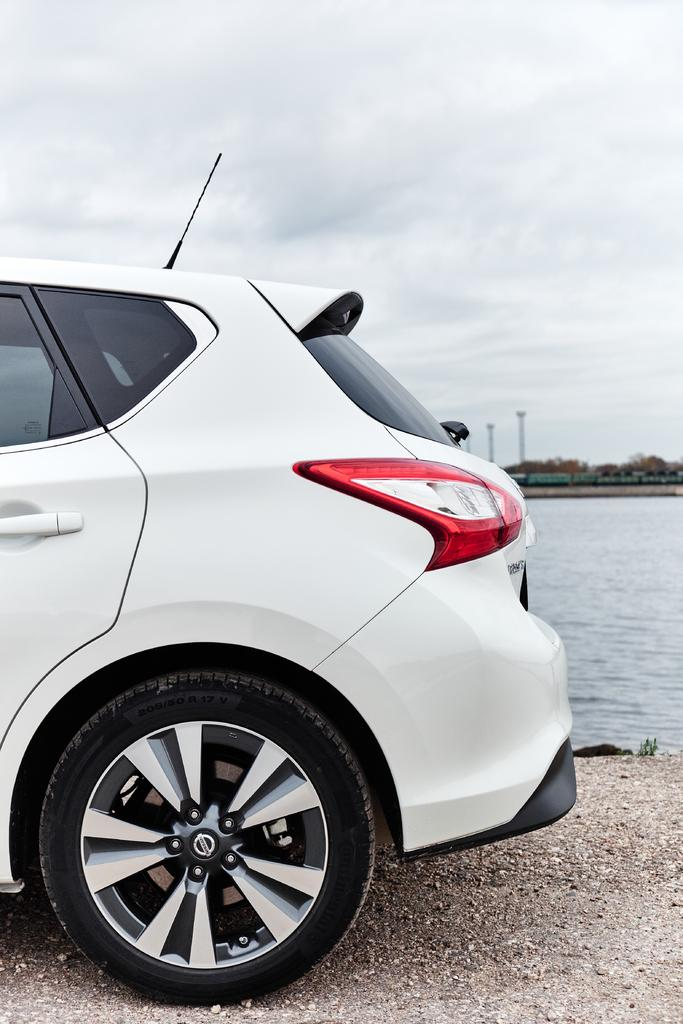What is the main subject of the image? There is a car in the image. Can you describe the color of the car? The car is white in color. What can be seen on the right side of the image? There is water visible on the right side of the image. What is visible in the background of the image? There are trees in the background of the image. What part of the natural environment is visible in the image? The sky is visible in the image. What type of advice can be heard coming from the car in the image? There is no indication in the image that the car is providing any advice, as cars do not have the ability to speak or give advice. 